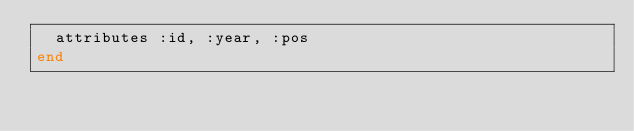Convert code to text. <code><loc_0><loc_0><loc_500><loc_500><_Ruby_>  attributes :id, :year, :pos
end
</code> 